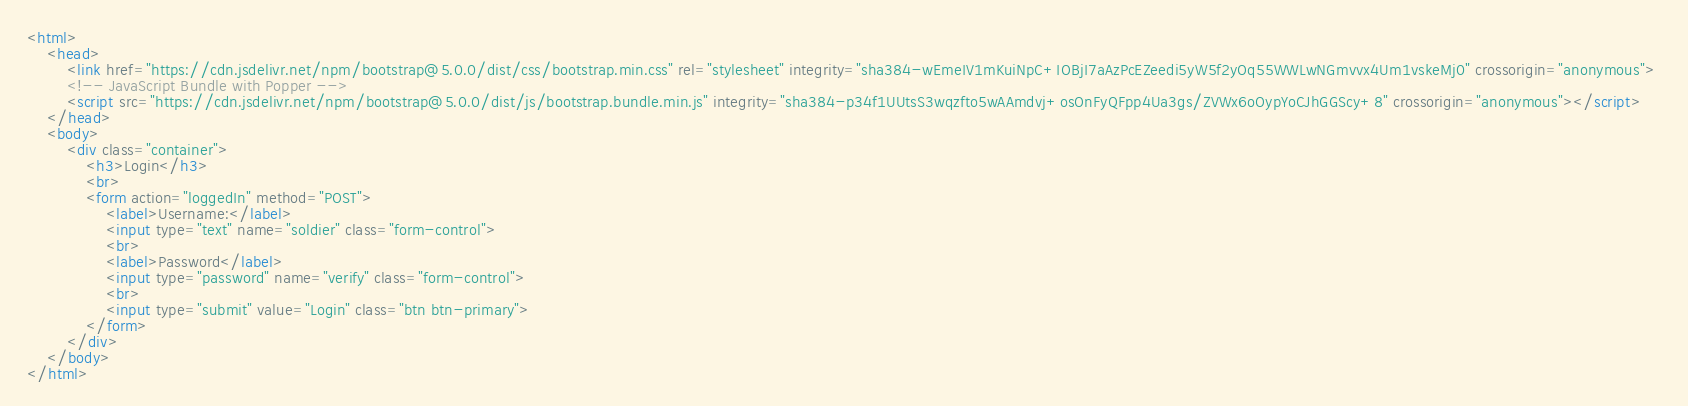<code> <loc_0><loc_0><loc_500><loc_500><_HTML_><html>
    <head>
        <link href="https://cdn.jsdelivr.net/npm/bootstrap@5.0.0/dist/css/bootstrap.min.css" rel="stylesheet" integrity="sha384-wEmeIV1mKuiNpC+IOBjI7aAzPcEZeedi5yW5f2yOq55WWLwNGmvvx4Um1vskeMj0" crossorigin="anonymous">
        <!-- JavaScript Bundle with Popper -->
        <script src="https://cdn.jsdelivr.net/npm/bootstrap@5.0.0/dist/js/bootstrap.bundle.min.js" integrity="sha384-p34f1UUtsS3wqzfto5wAAmdvj+osOnFyQFpp4Ua3gs/ZVWx6oOypYoCJhGGScy+8" crossorigin="anonymous"></script>    
    </head>
    <body>
        <div class="container">
            <h3>Login</h3>
            <br>
            <form action="loggedIn" method="POST">
                <label>Username:</label>
                <input type="text" name="soldier" class="form-control">
                <br>
                <label>Password</label>
                <input type="password" name="verify" class="form-control">
                <br>
                <input type="submit" value="Login" class="btn btn-primary">
            </form>
        </div>
    </body>
</html></code> 